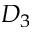<formula> <loc_0><loc_0><loc_500><loc_500>D _ { 3 }</formula> 